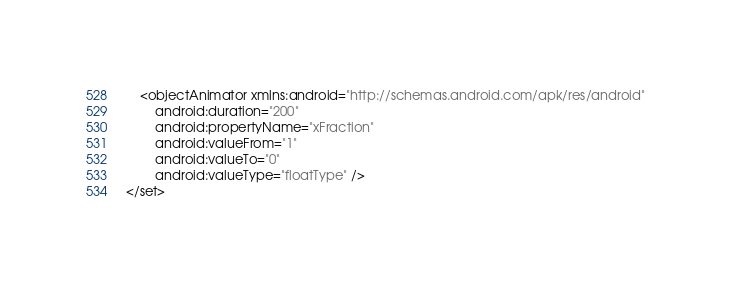<code> <loc_0><loc_0><loc_500><loc_500><_XML_>    <objectAnimator xmlns:android="http://schemas.android.com/apk/res/android"
        android:duration="200"
        android:propertyName="xFraction"
        android:valueFrom="1"
        android:valueTo="0"
        android:valueType="floatType" />
</set></code> 